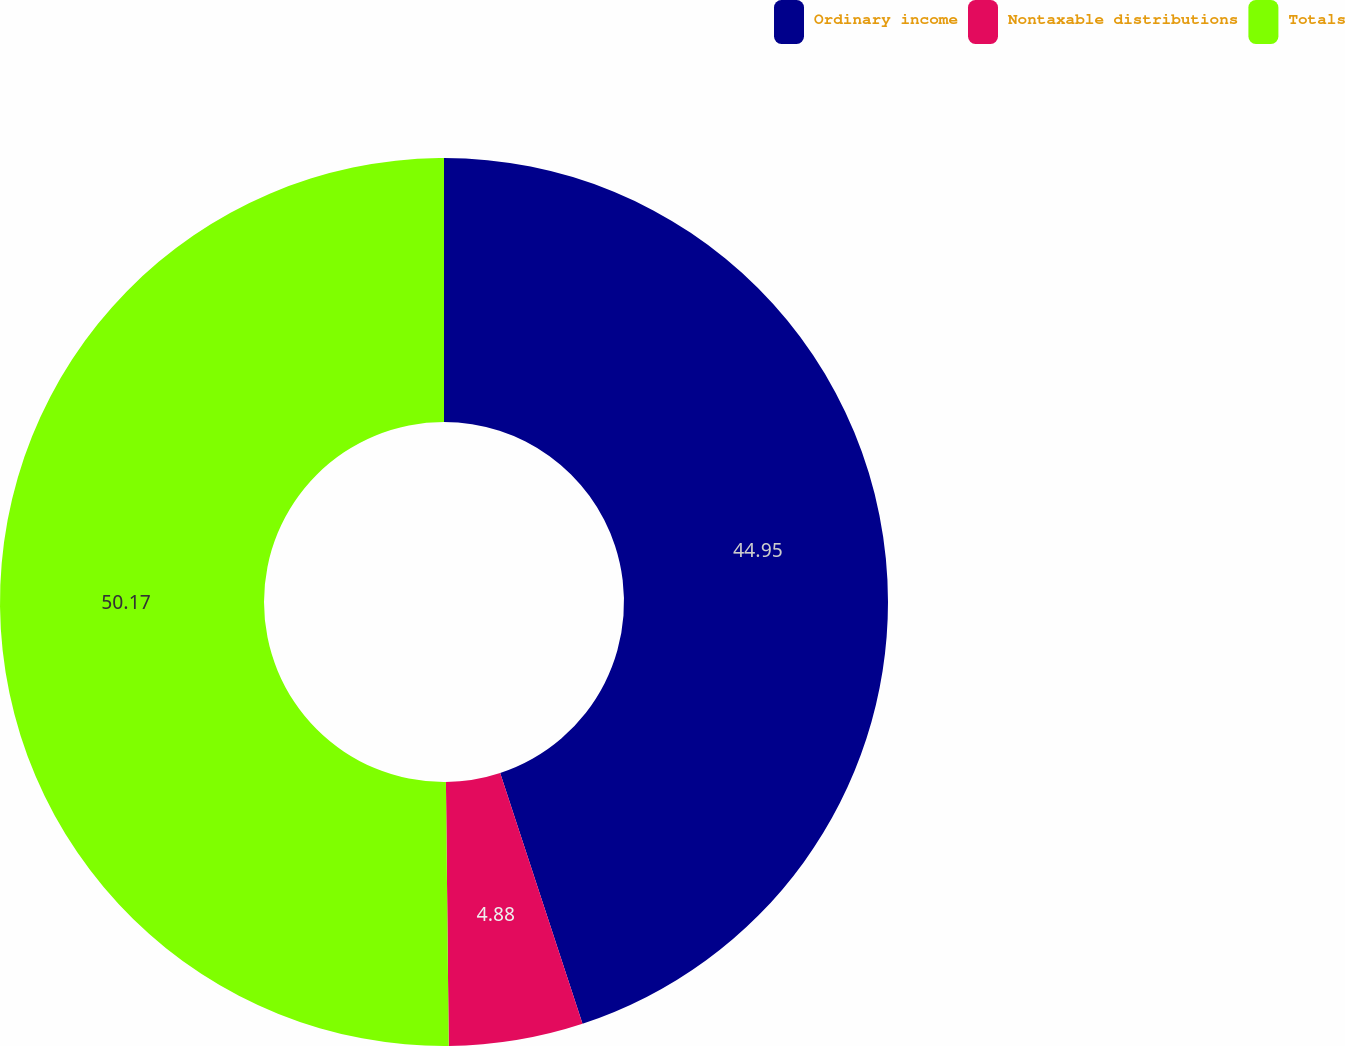Convert chart to OTSL. <chart><loc_0><loc_0><loc_500><loc_500><pie_chart><fcel>Ordinary income<fcel>Nontaxable distributions<fcel>Totals<nl><fcel>44.95%<fcel>4.88%<fcel>50.17%<nl></chart> 